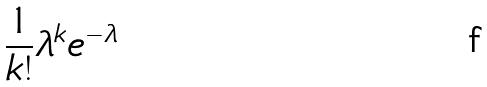Convert formula to latex. <formula><loc_0><loc_0><loc_500><loc_500>\frac { 1 } { k ! } \lambda ^ { k } e ^ { - \lambda }</formula> 